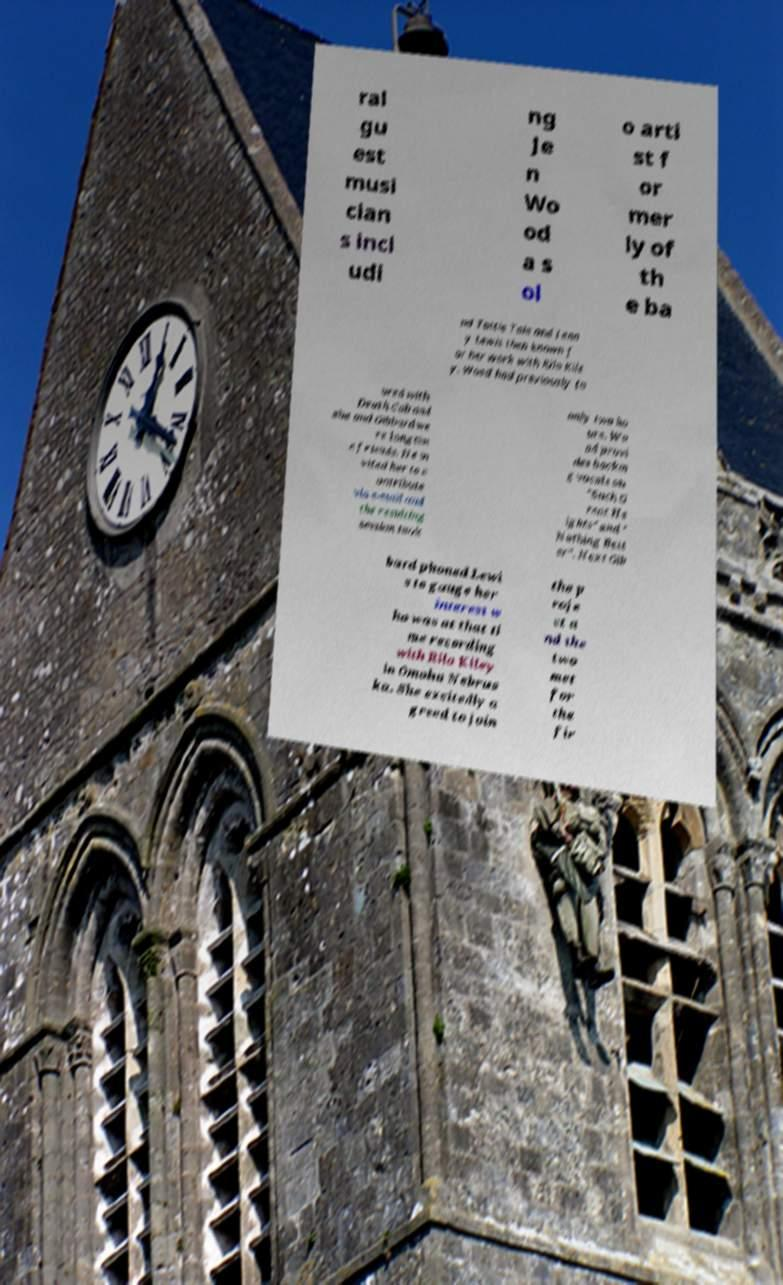There's text embedded in this image that I need extracted. Can you transcribe it verbatim? ral gu est musi cian s incl udi ng Je n Wo od a s ol o arti st f or mer ly of th e ba nd Tattle Tale and Jenn y Lewis then known f or her work with Rilo Kile y. Wood had previously to ured with Death Cab and she and Gibbard we re longtim e friends. He in vited her to c ontribute via e-mail and the resulting session took only two ho urs. Wo od provi des backin g vocals on "Such G reat He ights" and " Nothing Bett er". Next Gib bard phoned Lewi s to gauge her interest w ho was at that ti me recording with Rilo Kiley in Omaha Nebras ka. She excitedly a greed to join the p roje ct a nd the two met for the fir 